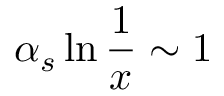Convert formula to latex. <formula><loc_0><loc_0><loc_500><loc_500>\alpha _ { s } \ln { \frac { 1 } { x } } \sim 1</formula> 